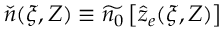Convert formula to latex. <formula><loc_0><loc_0><loc_500><loc_500>\check { n } ( \xi , Z ) \equiv \widetilde { n _ { 0 } } \left [ \hat { z } _ { e } ( \xi , Z ) \right ]</formula> 